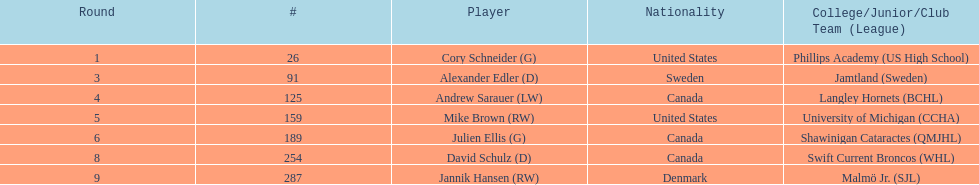What is the number of canadian players listed? 3. 